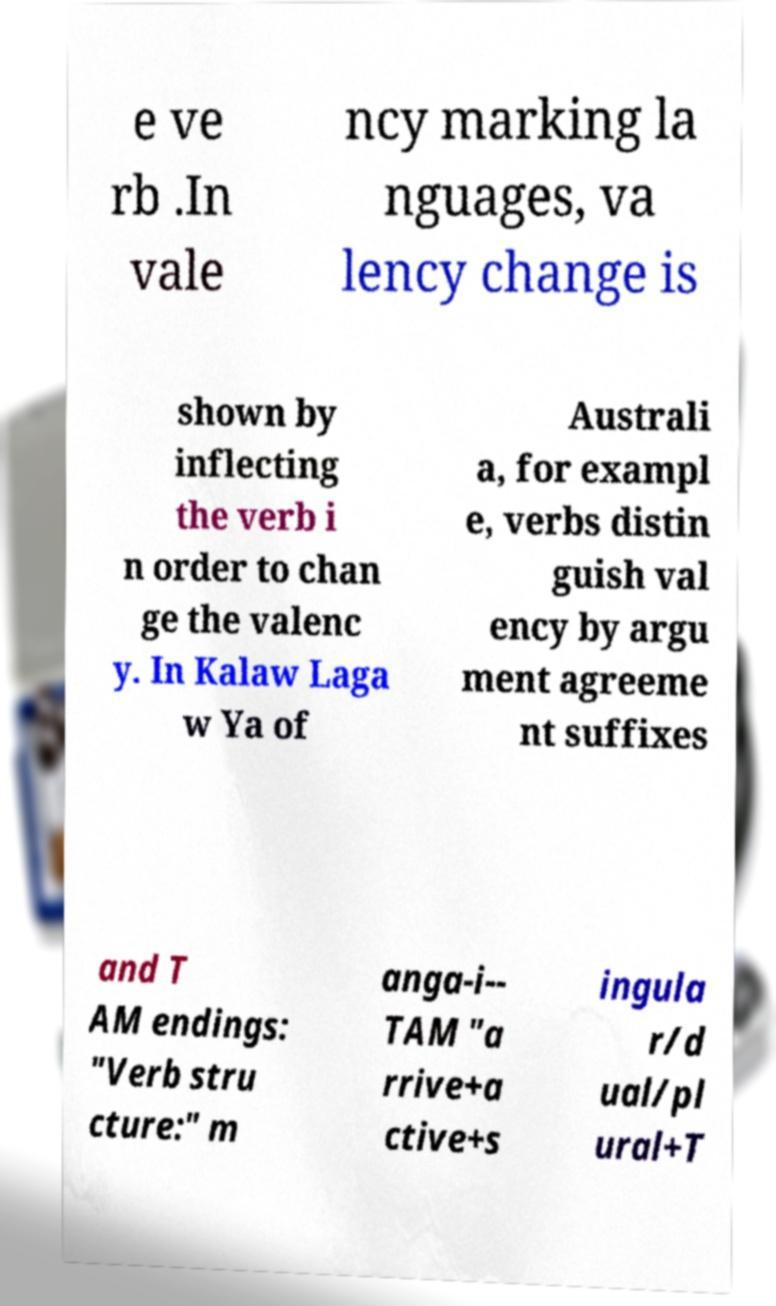Could you extract and type out the text from this image? e ve rb .In vale ncy marking la nguages, va lency change is shown by inflecting the verb i n order to chan ge the valenc y. In Kalaw Laga w Ya of Australi a, for exampl e, verbs distin guish val ency by argu ment agreeme nt suffixes and T AM endings: "Verb stru cture:" m anga-i-- TAM "a rrive+a ctive+s ingula r/d ual/pl ural+T 